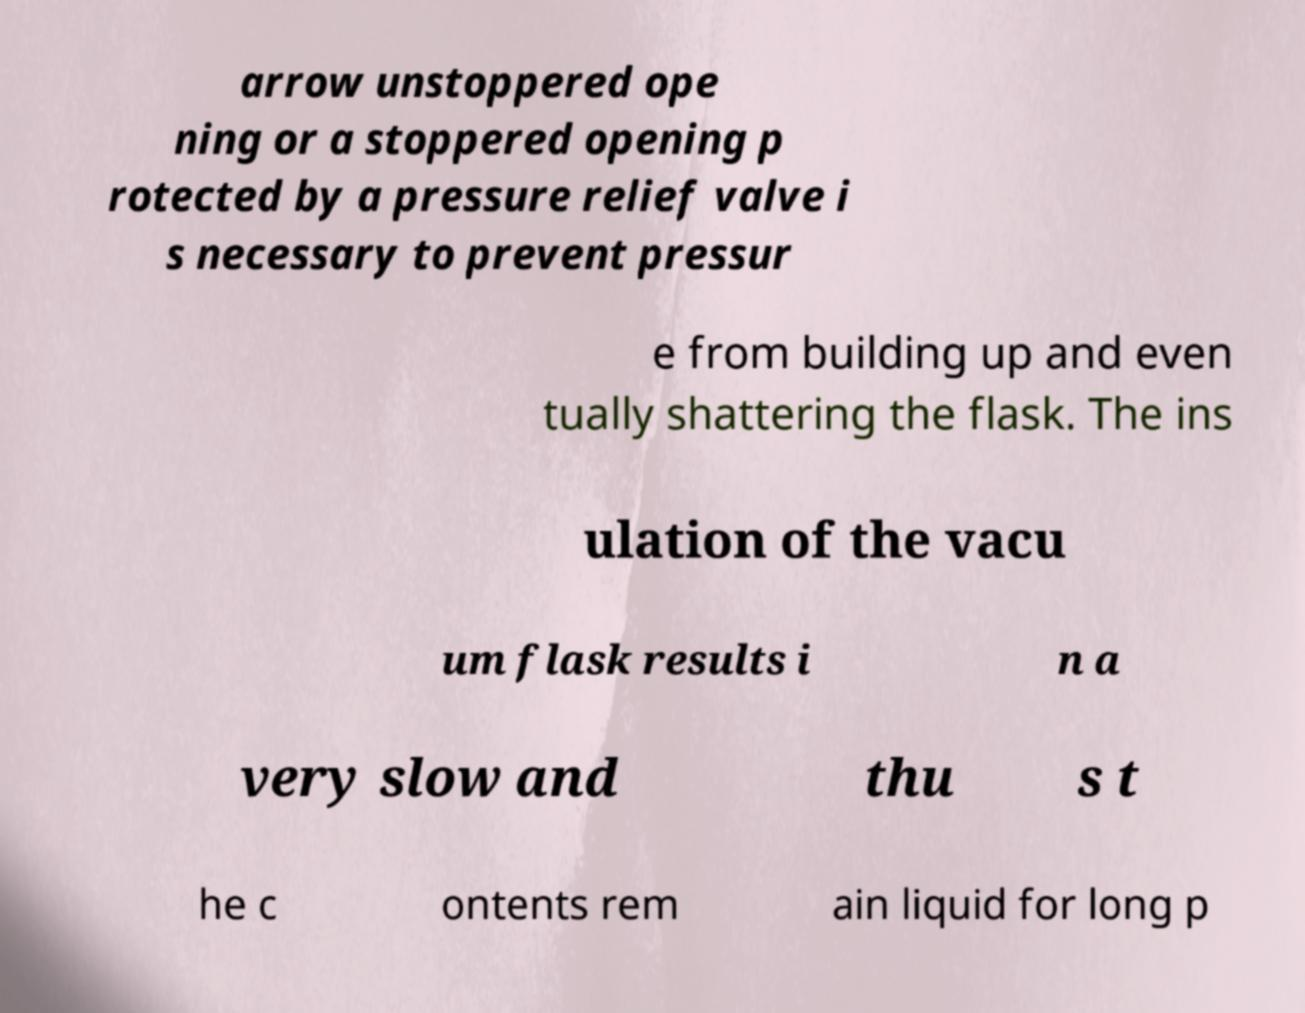Please identify and transcribe the text found in this image. arrow unstoppered ope ning or a stoppered opening p rotected by a pressure relief valve i s necessary to prevent pressur e from building up and even tually shattering the flask. The ins ulation of the vacu um flask results i n a very slow and thu s t he c ontents rem ain liquid for long p 